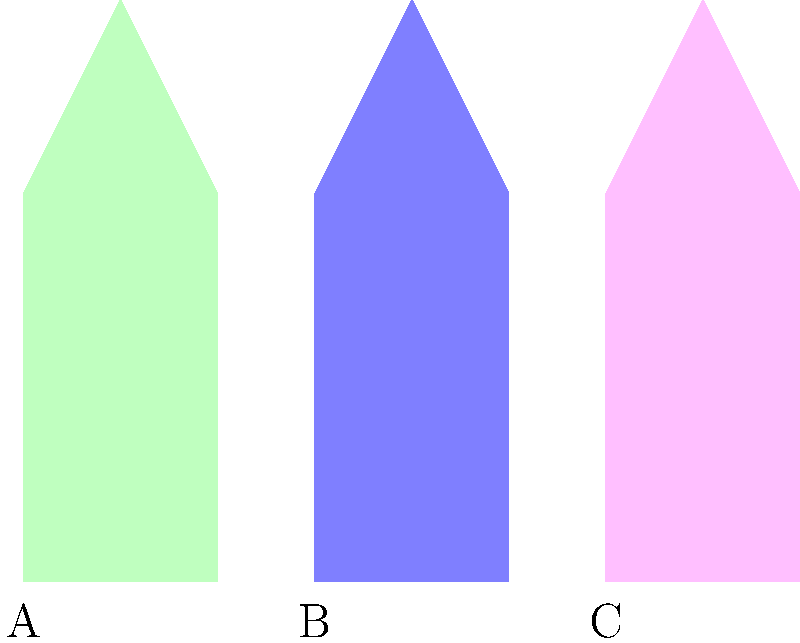Which hanbok style is traditionally worn by unmarried women during special occasions like Seollal (Korean New Year) or Chuseok (Korean Thanksgiving)? Let's analyze the three hanbok styles shown in the image:

1. Style A (Green): This appears to be a simpler, more modest design typical of everyday wear or for older women.

2. Style B (Blue): This style has a more fitted top and a fuller skirt, which is characteristic of the hanbok worn by married women.

3. Style C (Pink): This style features a high-waisted skirt and a shorter jacket, which is typical of the hanbok worn by young, unmarried women.

In Korean culture, unmarried women traditionally wear brightly colored hanboks with high-waisted skirts and shorter jackets during special occasions. This style allows for more movement and is considered more youthful and playful.

Given this information, the hanbok style traditionally worn by unmarried women during special occasions like Seollal or Chuseok is represented by Style C in the image.
Answer: Style C (Pink) 